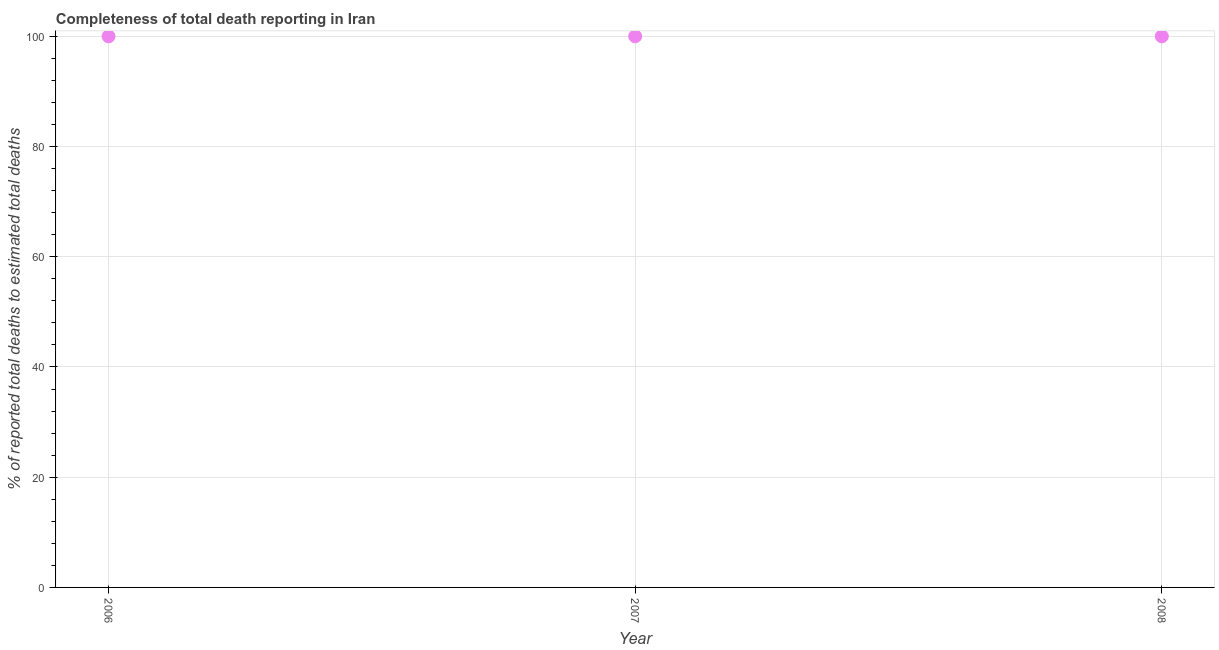What is the completeness of total death reports in 2007?
Ensure brevity in your answer.  100. Across all years, what is the maximum completeness of total death reports?
Provide a succinct answer. 100. Across all years, what is the minimum completeness of total death reports?
Ensure brevity in your answer.  100. In which year was the completeness of total death reports minimum?
Your answer should be compact. 2006. What is the sum of the completeness of total death reports?
Give a very brief answer. 300. What is the difference between the completeness of total death reports in 2006 and 2008?
Ensure brevity in your answer.  0. What is the median completeness of total death reports?
Offer a terse response. 100. Is the sum of the completeness of total death reports in 2006 and 2007 greater than the maximum completeness of total death reports across all years?
Your answer should be very brief. Yes. What is the difference between the highest and the lowest completeness of total death reports?
Your response must be concise. 0. In how many years, is the completeness of total death reports greater than the average completeness of total death reports taken over all years?
Ensure brevity in your answer.  0. Does the completeness of total death reports monotonically increase over the years?
Ensure brevity in your answer.  No. How many years are there in the graph?
Your answer should be compact. 3. What is the difference between two consecutive major ticks on the Y-axis?
Offer a terse response. 20. Does the graph contain any zero values?
Your response must be concise. No. What is the title of the graph?
Keep it short and to the point. Completeness of total death reporting in Iran. What is the label or title of the X-axis?
Provide a short and direct response. Year. What is the label or title of the Y-axis?
Offer a very short reply. % of reported total deaths to estimated total deaths. What is the % of reported total deaths to estimated total deaths in 2006?
Give a very brief answer. 100. What is the % of reported total deaths to estimated total deaths in 2007?
Ensure brevity in your answer.  100. What is the % of reported total deaths to estimated total deaths in 2008?
Provide a short and direct response. 100. What is the ratio of the % of reported total deaths to estimated total deaths in 2006 to that in 2008?
Make the answer very short. 1. 